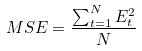Convert formula to latex. <formula><loc_0><loc_0><loc_500><loc_500>M S E = \frac { \sum _ { t = 1 } ^ { N } E _ { t } ^ { 2 } } { N }</formula> 